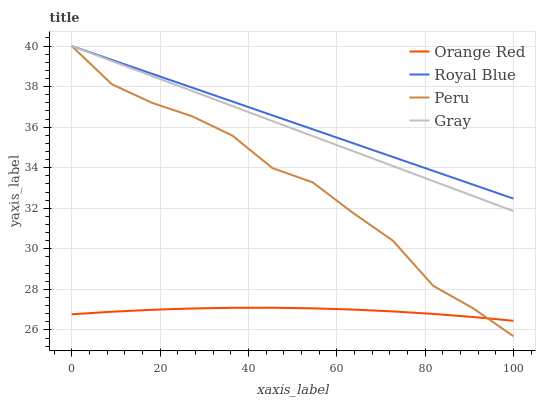Does Orange Red have the minimum area under the curve?
Answer yes or no. Yes. Does Royal Blue have the maximum area under the curve?
Answer yes or no. Yes. Does Peru have the minimum area under the curve?
Answer yes or no. No. Does Peru have the maximum area under the curve?
Answer yes or no. No. Is Royal Blue the smoothest?
Answer yes or no. Yes. Is Peru the roughest?
Answer yes or no. Yes. Is Orange Red the smoothest?
Answer yes or no. No. Is Orange Red the roughest?
Answer yes or no. No. Does Orange Red have the lowest value?
Answer yes or no. No. Does Gray have the highest value?
Answer yes or no. Yes. Does Orange Red have the highest value?
Answer yes or no. No. Is Orange Red less than Royal Blue?
Answer yes or no. Yes. Is Gray greater than Orange Red?
Answer yes or no. Yes. Does Royal Blue intersect Peru?
Answer yes or no. Yes. Is Royal Blue less than Peru?
Answer yes or no. No. Is Royal Blue greater than Peru?
Answer yes or no. No. Does Orange Red intersect Royal Blue?
Answer yes or no. No. 